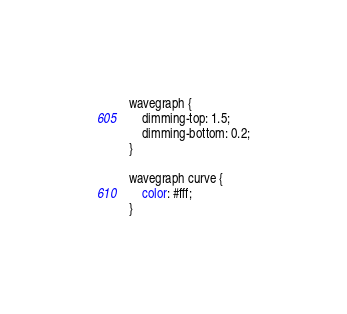Convert code to text. <code><loc_0><loc_0><loc_500><loc_500><_CSS_>
wavegraph {
	dimming-top: 1.5;
	dimming-bottom: 0.2;
}

wavegraph curve {
	color: #fff;
}
</code> 